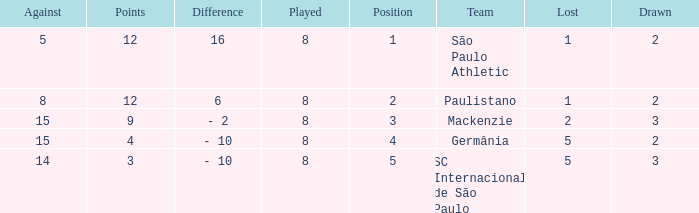What was the position with the total number less than 1? 0.0. 